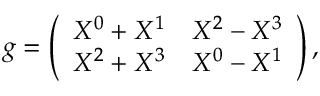<formula> <loc_0><loc_0><loc_500><loc_500>g = \left ( \begin{array} { c c c } { { X ^ { 0 } + X ^ { 1 } } } & { { X ^ { 2 } - X ^ { 3 } } } \\ { { X ^ { 2 } + X ^ { 3 } } } & { { X ^ { 0 } - X ^ { 1 } } } \end{array} \right ) ,</formula> 